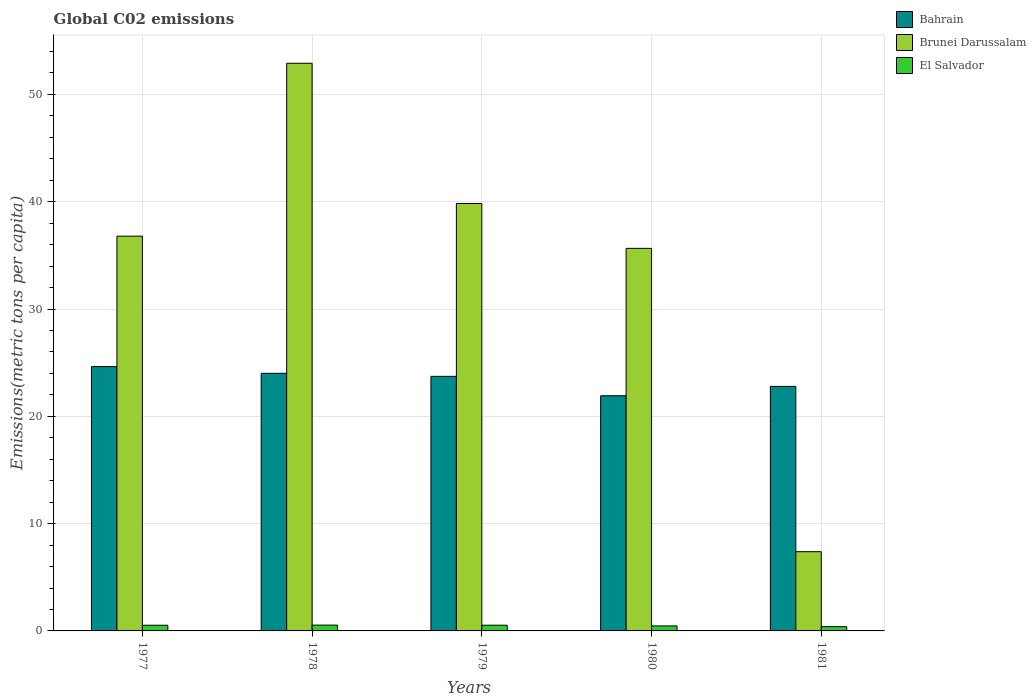Are the number of bars per tick equal to the number of legend labels?
Make the answer very short. Yes. How many bars are there on the 1st tick from the left?
Your answer should be very brief. 3. How many bars are there on the 3rd tick from the right?
Provide a succinct answer. 3. In how many cases, is the number of bars for a given year not equal to the number of legend labels?
Your answer should be very brief. 0. What is the amount of CO2 emitted in in El Salvador in 1981?
Keep it short and to the point. 0.39. Across all years, what is the maximum amount of CO2 emitted in in Bahrain?
Your response must be concise. 24.63. Across all years, what is the minimum amount of CO2 emitted in in El Salvador?
Provide a short and direct response. 0.39. In which year was the amount of CO2 emitted in in Brunei Darussalam maximum?
Provide a succinct answer. 1978. In which year was the amount of CO2 emitted in in Bahrain minimum?
Offer a very short reply. 1980. What is the total amount of CO2 emitted in in El Salvador in the graph?
Your answer should be very brief. 2.46. What is the difference between the amount of CO2 emitted in in El Salvador in 1978 and that in 1980?
Ensure brevity in your answer.  0.08. What is the difference between the amount of CO2 emitted in in Bahrain in 1978 and the amount of CO2 emitted in in Brunei Darussalam in 1980?
Your answer should be very brief. -11.64. What is the average amount of CO2 emitted in in El Salvador per year?
Your answer should be compact. 0.49. In the year 1981, what is the difference between the amount of CO2 emitted in in Brunei Darussalam and amount of CO2 emitted in in Bahrain?
Your answer should be very brief. -15.4. What is the ratio of the amount of CO2 emitted in in El Salvador in 1977 to that in 1981?
Provide a succinct answer. 1.34. Is the amount of CO2 emitted in in Bahrain in 1979 less than that in 1980?
Keep it short and to the point. No. Is the difference between the amount of CO2 emitted in in Brunei Darussalam in 1979 and 1980 greater than the difference between the amount of CO2 emitted in in Bahrain in 1979 and 1980?
Your response must be concise. Yes. What is the difference between the highest and the second highest amount of CO2 emitted in in Bahrain?
Your answer should be compact. 0.63. What is the difference between the highest and the lowest amount of CO2 emitted in in Bahrain?
Your answer should be compact. 2.72. In how many years, is the amount of CO2 emitted in in El Salvador greater than the average amount of CO2 emitted in in El Salvador taken over all years?
Provide a short and direct response. 3. Is the sum of the amount of CO2 emitted in in Bahrain in 1980 and 1981 greater than the maximum amount of CO2 emitted in in Brunei Darussalam across all years?
Keep it short and to the point. No. What does the 2nd bar from the left in 1981 represents?
Offer a very short reply. Brunei Darussalam. What does the 2nd bar from the right in 1978 represents?
Ensure brevity in your answer.  Brunei Darussalam. Are all the bars in the graph horizontal?
Ensure brevity in your answer.  No. What is the difference between two consecutive major ticks on the Y-axis?
Ensure brevity in your answer.  10. Are the values on the major ticks of Y-axis written in scientific E-notation?
Give a very brief answer. No. Does the graph contain any zero values?
Provide a short and direct response. No. How are the legend labels stacked?
Your answer should be very brief. Vertical. What is the title of the graph?
Your answer should be very brief. Global C02 emissions. Does "Kiribati" appear as one of the legend labels in the graph?
Provide a succinct answer. No. What is the label or title of the X-axis?
Make the answer very short. Years. What is the label or title of the Y-axis?
Make the answer very short. Emissions(metric tons per capita). What is the Emissions(metric tons per capita) in Bahrain in 1977?
Your answer should be very brief. 24.63. What is the Emissions(metric tons per capita) in Brunei Darussalam in 1977?
Your answer should be compact. 36.79. What is the Emissions(metric tons per capita) of El Salvador in 1977?
Give a very brief answer. 0.53. What is the Emissions(metric tons per capita) in Bahrain in 1978?
Offer a very short reply. 24.01. What is the Emissions(metric tons per capita) of Brunei Darussalam in 1978?
Provide a succinct answer. 52.9. What is the Emissions(metric tons per capita) in El Salvador in 1978?
Your answer should be compact. 0.54. What is the Emissions(metric tons per capita) of Bahrain in 1979?
Give a very brief answer. 23.72. What is the Emissions(metric tons per capita) of Brunei Darussalam in 1979?
Your response must be concise. 39.83. What is the Emissions(metric tons per capita) in El Salvador in 1979?
Keep it short and to the point. 0.53. What is the Emissions(metric tons per capita) of Bahrain in 1980?
Make the answer very short. 21.92. What is the Emissions(metric tons per capita) in Brunei Darussalam in 1980?
Ensure brevity in your answer.  35.65. What is the Emissions(metric tons per capita) of El Salvador in 1980?
Make the answer very short. 0.47. What is the Emissions(metric tons per capita) of Bahrain in 1981?
Your answer should be very brief. 22.79. What is the Emissions(metric tons per capita) of Brunei Darussalam in 1981?
Provide a short and direct response. 7.38. What is the Emissions(metric tons per capita) of El Salvador in 1981?
Offer a terse response. 0.39. Across all years, what is the maximum Emissions(metric tons per capita) of Bahrain?
Ensure brevity in your answer.  24.63. Across all years, what is the maximum Emissions(metric tons per capita) in Brunei Darussalam?
Offer a very short reply. 52.9. Across all years, what is the maximum Emissions(metric tons per capita) of El Salvador?
Your answer should be compact. 0.54. Across all years, what is the minimum Emissions(metric tons per capita) of Bahrain?
Provide a succinct answer. 21.92. Across all years, what is the minimum Emissions(metric tons per capita) of Brunei Darussalam?
Provide a succinct answer. 7.38. Across all years, what is the minimum Emissions(metric tons per capita) of El Salvador?
Provide a succinct answer. 0.39. What is the total Emissions(metric tons per capita) of Bahrain in the graph?
Offer a very short reply. 117.07. What is the total Emissions(metric tons per capita) in Brunei Darussalam in the graph?
Make the answer very short. 172.56. What is the total Emissions(metric tons per capita) of El Salvador in the graph?
Offer a terse response. 2.46. What is the difference between the Emissions(metric tons per capita) of Bahrain in 1977 and that in 1978?
Offer a very short reply. 0.63. What is the difference between the Emissions(metric tons per capita) in Brunei Darussalam in 1977 and that in 1978?
Provide a succinct answer. -16.11. What is the difference between the Emissions(metric tons per capita) in El Salvador in 1977 and that in 1978?
Your answer should be very brief. -0.01. What is the difference between the Emissions(metric tons per capita) in Bahrain in 1977 and that in 1979?
Offer a very short reply. 0.91. What is the difference between the Emissions(metric tons per capita) of Brunei Darussalam in 1977 and that in 1979?
Make the answer very short. -3.04. What is the difference between the Emissions(metric tons per capita) in El Salvador in 1977 and that in 1979?
Offer a very short reply. -0. What is the difference between the Emissions(metric tons per capita) in Bahrain in 1977 and that in 1980?
Your response must be concise. 2.72. What is the difference between the Emissions(metric tons per capita) in Brunei Darussalam in 1977 and that in 1980?
Make the answer very short. 1.14. What is the difference between the Emissions(metric tons per capita) in El Salvador in 1977 and that in 1980?
Your answer should be very brief. 0.06. What is the difference between the Emissions(metric tons per capita) in Bahrain in 1977 and that in 1981?
Provide a succinct answer. 1.84. What is the difference between the Emissions(metric tons per capita) in Brunei Darussalam in 1977 and that in 1981?
Keep it short and to the point. 29.41. What is the difference between the Emissions(metric tons per capita) in El Salvador in 1977 and that in 1981?
Give a very brief answer. 0.13. What is the difference between the Emissions(metric tons per capita) of Bahrain in 1978 and that in 1979?
Keep it short and to the point. 0.28. What is the difference between the Emissions(metric tons per capita) in Brunei Darussalam in 1978 and that in 1979?
Provide a short and direct response. 13.07. What is the difference between the Emissions(metric tons per capita) in Bahrain in 1978 and that in 1980?
Give a very brief answer. 2.09. What is the difference between the Emissions(metric tons per capita) in Brunei Darussalam in 1978 and that in 1980?
Keep it short and to the point. 17.25. What is the difference between the Emissions(metric tons per capita) in El Salvador in 1978 and that in 1980?
Offer a terse response. 0.08. What is the difference between the Emissions(metric tons per capita) in Bahrain in 1978 and that in 1981?
Ensure brevity in your answer.  1.22. What is the difference between the Emissions(metric tons per capita) in Brunei Darussalam in 1978 and that in 1981?
Keep it short and to the point. 45.52. What is the difference between the Emissions(metric tons per capita) in El Salvador in 1978 and that in 1981?
Make the answer very short. 0.15. What is the difference between the Emissions(metric tons per capita) of Bahrain in 1979 and that in 1980?
Provide a short and direct response. 1.81. What is the difference between the Emissions(metric tons per capita) in Brunei Darussalam in 1979 and that in 1980?
Offer a terse response. 4.18. What is the difference between the Emissions(metric tons per capita) of El Salvador in 1979 and that in 1980?
Offer a very short reply. 0.07. What is the difference between the Emissions(metric tons per capita) of Bahrain in 1979 and that in 1981?
Your answer should be very brief. 0.94. What is the difference between the Emissions(metric tons per capita) in Brunei Darussalam in 1979 and that in 1981?
Give a very brief answer. 32.45. What is the difference between the Emissions(metric tons per capita) of El Salvador in 1979 and that in 1981?
Offer a terse response. 0.14. What is the difference between the Emissions(metric tons per capita) of Bahrain in 1980 and that in 1981?
Keep it short and to the point. -0.87. What is the difference between the Emissions(metric tons per capita) in Brunei Darussalam in 1980 and that in 1981?
Ensure brevity in your answer.  28.27. What is the difference between the Emissions(metric tons per capita) in El Salvador in 1980 and that in 1981?
Your answer should be very brief. 0.07. What is the difference between the Emissions(metric tons per capita) in Bahrain in 1977 and the Emissions(metric tons per capita) in Brunei Darussalam in 1978?
Provide a short and direct response. -28.27. What is the difference between the Emissions(metric tons per capita) in Bahrain in 1977 and the Emissions(metric tons per capita) in El Salvador in 1978?
Provide a succinct answer. 24.09. What is the difference between the Emissions(metric tons per capita) of Brunei Darussalam in 1977 and the Emissions(metric tons per capita) of El Salvador in 1978?
Give a very brief answer. 36.25. What is the difference between the Emissions(metric tons per capita) of Bahrain in 1977 and the Emissions(metric tons per capita) of Brunei Darussalam in 1979?
Your answer should be compact. -15.2. What is the difference between the Emissions(metric tons per capita) in Bahrain in 1977 and the Emissions(metric tons per capita) in El Salvador in 1979?
Make the answer very short. 24.1. What is the difference between the Emissions(metric tons per capita) in Brunei Darussalam in 1977 and the Emissions(metric tons per capita) in El Salvador in 1979?
Give a very brief answer. 36.26. What is the difference between the Emissions(metric tons per capita) of Bahrain in 1977 and the Emissions(metric tons per capita) of Brunei Darussalam in 1980?
Keep it short and to the point. -11.02. What is the difference between the Emissions(metric tons per capita) in Bahrain in 1977 and the Emissions(metric tons per capita) in El Salvador in 1980?
Your response must be concise. 24.17. What is the difference between the Emissions(metric tons per capita) of Brunei Darussalam in 1977 and the Emissions(metric tons per capita) of El Salvador in 1980?
Provide a short and direct response. 36.32. What is the difference between the Emissions(metric tons per capita) in Bahrain in 1977 and the Emissions(metric tons per capita) in Brunei Darussalam in 1981?
Your response must be concise. 17.25. What is the difference between the Emissions(metric tons per capita) in Bahrain in 1977 and the Emissions(metric tons per capita) in El Salvador in 1981?
Offer a terse response. 24.24. What is the difference between the Emissions(metric tons per capita) of Brunei Darussalam in 1977 and the Emissions(metric tons per capita) of El Salvador in 1981?
Give a very brief answer. 36.4. What is the difference between the Emissions(metric tons per capita) in Bahrain in 1978 and the Emissions(metric tons per capita) in Brunei Darussalam in 1979?
Keep it short and to the point. -15.83. What is the difference between the Emissions(metric tons per capita) of Bahrain in 1978 and the Emissions(metric tons per capita) of El Salvador in 1979?
Ensure brevity in your answer.  23.48. What is the difference between the Emissions(metric tons per capita) in Brunei Darussalam in 1978 and the Emissions(metric tons per capita) in El Salvador in 1979?
Give a very brief answer. 52.37. What is the difference between the Emissions(metric tons per capita) of Bahrain in 1978 and the Emissions(metric tons per capita) of Brunei Darussalam in 1980?
Offer a very short reply. -11.64. What is the difference between the Emissions(metric tons per capita) in Bahrain in 1978 and the Emissions(metric tons per capita) in El Salvador in 1980?
Your answer should be compact. 23.54. What is the difference between the Emissions(metric tons per capita) in Brunei Darussalam in 1978 and the Emissions(metric tons per capita) in El Salvador in 1980?
Provide a short and direct response. 52.44. What is the difference between the Emissions(metric tons per capita) of Bahrain in 1978 and the Emissions(metric tons per capita) of Brunei Darussalam in 1981?
Give a very brief answer. 16.62. What is the difference between the Emissions(metric tons per capita) of Bahrain in 1978 and the Emissions(metric tons per capita) of El Salvador in 1981?
Offer a very short reply. 23.61. What is the difference between the Emissions(metric tons per capita) of Brunei Darussalam in 1978 and the Emissions(metric tons per capita) of El Salvador in 1981?
Your response must be concise. 52.51. What is the difference between the Emissions(metric tons per capita) of Bahrain in 1979 and the Emissions(metric tons per capita) of Brunei Darussalam in 1980?
Provide a short and direct response. -11.93. What is the difference between the Emissions(metric tons per capita) in Bahrain in 1979 and the Emissions(metric tons per capita) in El Salvador in 1980?
Provide a succinct answer. 23.26. What is the difference between the Emissions(metric tons per capita) in Brunei Darussalam in 1979 and the Emissions(metric tons per capita) in El Salvador in 1980?
Make the answer very short. 39.37. What is the difference between the Emissions(metric tons per capita) of Bahrain in 1979 and the Emissions(metric tons per capita) of Brunei Darussalam in 1981?
Make the answer very short. 16.34. What is the difference between the Emissions(metric tons per capita) of Bahrain in 1979 and the Emissions(metric tons per capita) of El Salvador in 1981?
Keep it short and to the point. 23.33. What is the difference between the Emissions(metric tons per capita) of Brunei Darussalam in 1979 and the Emissions(metric tons per capita) of El Salvador in 1981?
Your response must be concise. 39.44. What is the difference between the Emissions(metric tons per capita) in Bahrain in 1980 and the Emissions(metric tons per capita) in Brunei Darussalam in 1981?
Keep it short and to the point. 14.53. What is the difference between the Emissions(metric tons per capita) in Bahrain in 1980 and the Emissions(metric tons per capita) in El Salvador in 1981?
Make the answer very short. 21.52. What is the difference between the Emissions(metric tons per capita) of Brunei Darussalam in 1980 and the Emissions(metric tons per capita) of El Salvador in 1981?
Make the answer very short. 35.26. What is the average Emissions(metric tons per capita) of Bahrain per year?
Give a very brief answer. 23.41. What is the average Emissions(metric tons per capita) of Brunei Darussalam per year?
Make the answer very short. 34.51. What is the average Emissions(metric tons per capita) of El Salvador per year?
Your answer should be very brief. 0.49. In the year 1977, what is the difference between the Emissions(metric tons per capita) of Bahrain and Emissions(metric tons per capita) of Brunei Darussalam?
Provide a short and direct response. -12.16. In the year 1977, what is the difference between the Emissions(metric tons per capita) in Bahrain and Emissions(metric tons per capita) in El Salvador?
Ensure brevity in your answer.  24.1. In the year 1977, what is the difference between the Emissions(metric tons per capita) of Brunei Darussalam and Emissions(metric tons per capita) of El Salvador?
Provide a short and direct response. 36.26. In the year 1978, what is the difference between the Emissions(metric tons per capita) in Bahrain and Emissions(metric tons per capita) in Brunei Darussalam?
Your response must be concise. -28.9. In the year 1978, what is the difference between the Emissions(metric tons per capita) of Bahrain and Emissions(metric tons per capita) of El Salvador?
Offer a very short reply. 23.47. In the year 1978, what is the difference between the Emissions(metric tons per capita) of Brunei Darussalam and Emissions(metric tons per capita) of El Salvador?
Provide a succinct answer. 52.36. In the year 1979, what is the difference between the Emissions(metric tons per capita) in Bahrain and Emissions(metric tons per capita) in Brunei Darussalam?
Offer a very short reply. -16.11. In the year 1979, what is the difference between the Emissions(metric tons per capita) in Bahrain and Emissions(metric tons per capita) in El Salvador?
Give a very brief answer. 23.19. In the year 1979, what is the difference between the Emissions(metric tons per capita) of Brunei Darussalam and Emissions(metric tons per capita) of El Salvador?
Offer a very short reply. 39.3. In the year 1980, what is the difference between the Emissions(metric tons per capita) in Bahrain and Emissions(metric tons per capita) in Brunei Darussalam?
Provide a short and direct response. -13.74. In the year 1980, what is the difference between the Emissions(metric tons per capita) of Bahrain and Emissions(metric tons per capita) of El Salvador?
Give a very brief answer. 21.45. In the year 1980, what is the difference between the Emissions(metric tons per capita) of Brunei Darussalam and Emissions(metric tons per capita) of El Salvador?
Offer a very short reply. 35.19. In the year 1981, what is the difference between the Emissions(metric tons per capita) of Bahrain and Emissions(metric tons per capita) of Brunei Darussalam?
Offer a very short reply. 15.4. In the year 1981, what is the difference between the Emissions(metric tons per capita) of Bahrain and Emissions(metric tons per capita) of El Salvador?
Offer a terse response. 22.39. In the year 1981, what is the difference between the Emissions(metric tons per capita) in Brunei Darussalam and Emissions(metric tons per capita) in El Salvador?
Your answer should be compact. 6.99. What is the ratio of the Emissions(metric tons per capita) in Bahrain in 1977 to that in 1978?
Provide a succinct answer. 1.03. What is the ratio of the Emissions(metric tons per capita) in Brunei Darussalam in 1977 to that in 1978?
Provide a succinct answer. 0.7. What is the ratio of the Emissions(metric tons per capita) of El Salvador in 1977 to that in 1978?
Your response must be concise. 0.98. What is the ratio of the Emissions(metric tons per capita) in Bahrain in 1977 to that in 1979?
Offer a terse response. 1.04. What is the ratio of the Emissions(metric tons per capita) in Brunei Darussalam in 1977 to that in 1979?
Offer a very short reply. 0.92. What is the ratio of the Emissions(metric tons per capita) of El Salvador in 1977 to that in 1979?
Provide a succinct answer. 0.99. What is the ratio of the Emissions(metric tons per capita) in Bahrain in 1977 to that in 1980?
Provide a succinct answer. 1.12. What is the ratio of the Emissions(metric tons per capita) of Brunei Darussalam in 1977 to that in 1980?
Make the answer very short. 1.03. What is the ratio of the Emissions(metric tons per capita) in El Salvador in 1977 to that in 1980?
Ensure brevity in your answer.  1.13. What is the ratio of the Emissions(metric tons per capita) in Bahrain in 1977 to that in 1981?
Your answer should be compact. 1.08. What is the ratio of the Emissions(metric tons per capita) in Brunei Darussalam in 1977 to that in 1981?
Keep it short and to the point. 4.98. What is the ratio of the Emissions(metric tons per capita) of El Salvador in 1977 to that in 1981?
Your answer should be very brief. 1.34. What is the ratio of the Emissions(metric tons per capita) of Bahrain in 1978 to that in 1979?
Provide a succinct answer. 1.01. What is the ratio of the Emissions(metric tons per capita) of Brunei Darussalam in 1978 to that in 1979?
Provide a short and direct response. 1.33. What is the ratio of the Emissions(metric tons per capita) in El Salvador in 1978 to that in 1979?
Your answer should be very brief. 1.02. What is the ratio of the Emissions(metric tons per capita) of Bahrain in 1978 to that in 1980?
Your response must be concise. 1.1. What is the ratio of the Emissions(metric tons per capita) of Brunei Darussalam in 1978 to that in 1980?
Your answer should be very brief. 1.48. What is the ratio of the Emissions(metric tons per capita) in El Salvador in 1978 to that in 1980?
Offer a terse response. 1.16. What is the ratio of the Emissions(metric tons per capita) in Bahrain in 1978 to that in 1981?
Keep it short and to the point. 1.05. What is the ratio of the Emissions(metric tons per capita) in Brunei Darussalam in 1978 to that in 1981?
Offer a very short reply. 7.16. What is the ratio of the Emissions(metric tons per capita) in El Salvador in 1978 to that in 1981?
Keep it short and to the point. 1.37. What is the ratio of the Emissions(metric tons per capita) of Bahrain in 1979 to that in 1980?
Provide a succinct answer. 1.08. What is the ratio of the Emissions(metric tons per capita) of Brunei Darussalam in 1979 to that in 1980?
Your answer should be very brief. 1.12. What is the ratio of the Emissions(metric tons per capita) of El Salvador in 1979 to that in 1980?
Your answer should be compact. 1.14. What is the ratio of the Emissions(metric tons per capita) of Bahrain in 1979 to that in 1981?
Keep it short and to the point. 1.04. What is the ratio of the Emissions(metric tons per capita) in Brunei Darussalam in 1979 to that in 1981?
Provide a succinct answer. 5.39. What is the ratio of the Emissions(metric tons per capita) of El Salvador in 1979 to that in 1981?
Provide a short and direct response. 1.35. What is the ratio of the Emissions(metric tons per capita) in Bahrain in 1980 to that in 1981?
Provide a succinct answer. 0.96. What is the ratio of the Emissions(metric tons per capita) in Brunei Darussalam in 1980 to that in 1981?
Your answer should be compact. 4.83. What is the ratio of the Emissions(metric tons per capita) of El Salvador in 1980 to that in 1981?
Make the answer very short. 1.18. What is the difference between the highest and the second highest Emissions(metric tons per capita) in Bahrain?
Your answer should be very brief. 0.63. What is the difference between the highest and the second highest Emissions(metric tons per capita) of Brunei Darussalam?
Provide a succinct answer. 13.07. What is the difference between the highest and the lowest Emissions(metric tons per capita) of Bahrain?
Provide a succinct answer. 2.72. What is the difference between the highest and the lowest Emissions(metric tons per capita) in Brunei Darussalam?
Give a very brief answer. 45.52. What is the difference between the highest and the lowest Emissions(metric tons per capita) of El Salvador?
Provide a short and direct response. 0.15. 